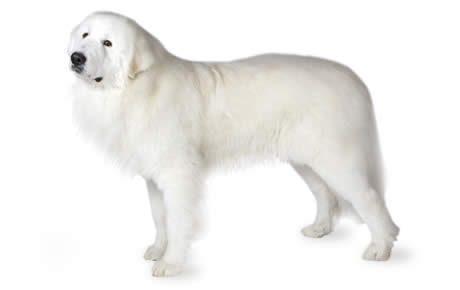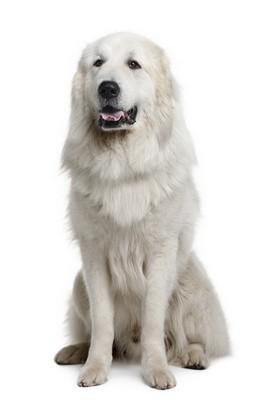The first image is the image on the left, the second image is the image on the right. Examine the images to the left and right. Is the description "One of the dogs is sitting in front of the sofa." accurate? Answer yes or no. No. 